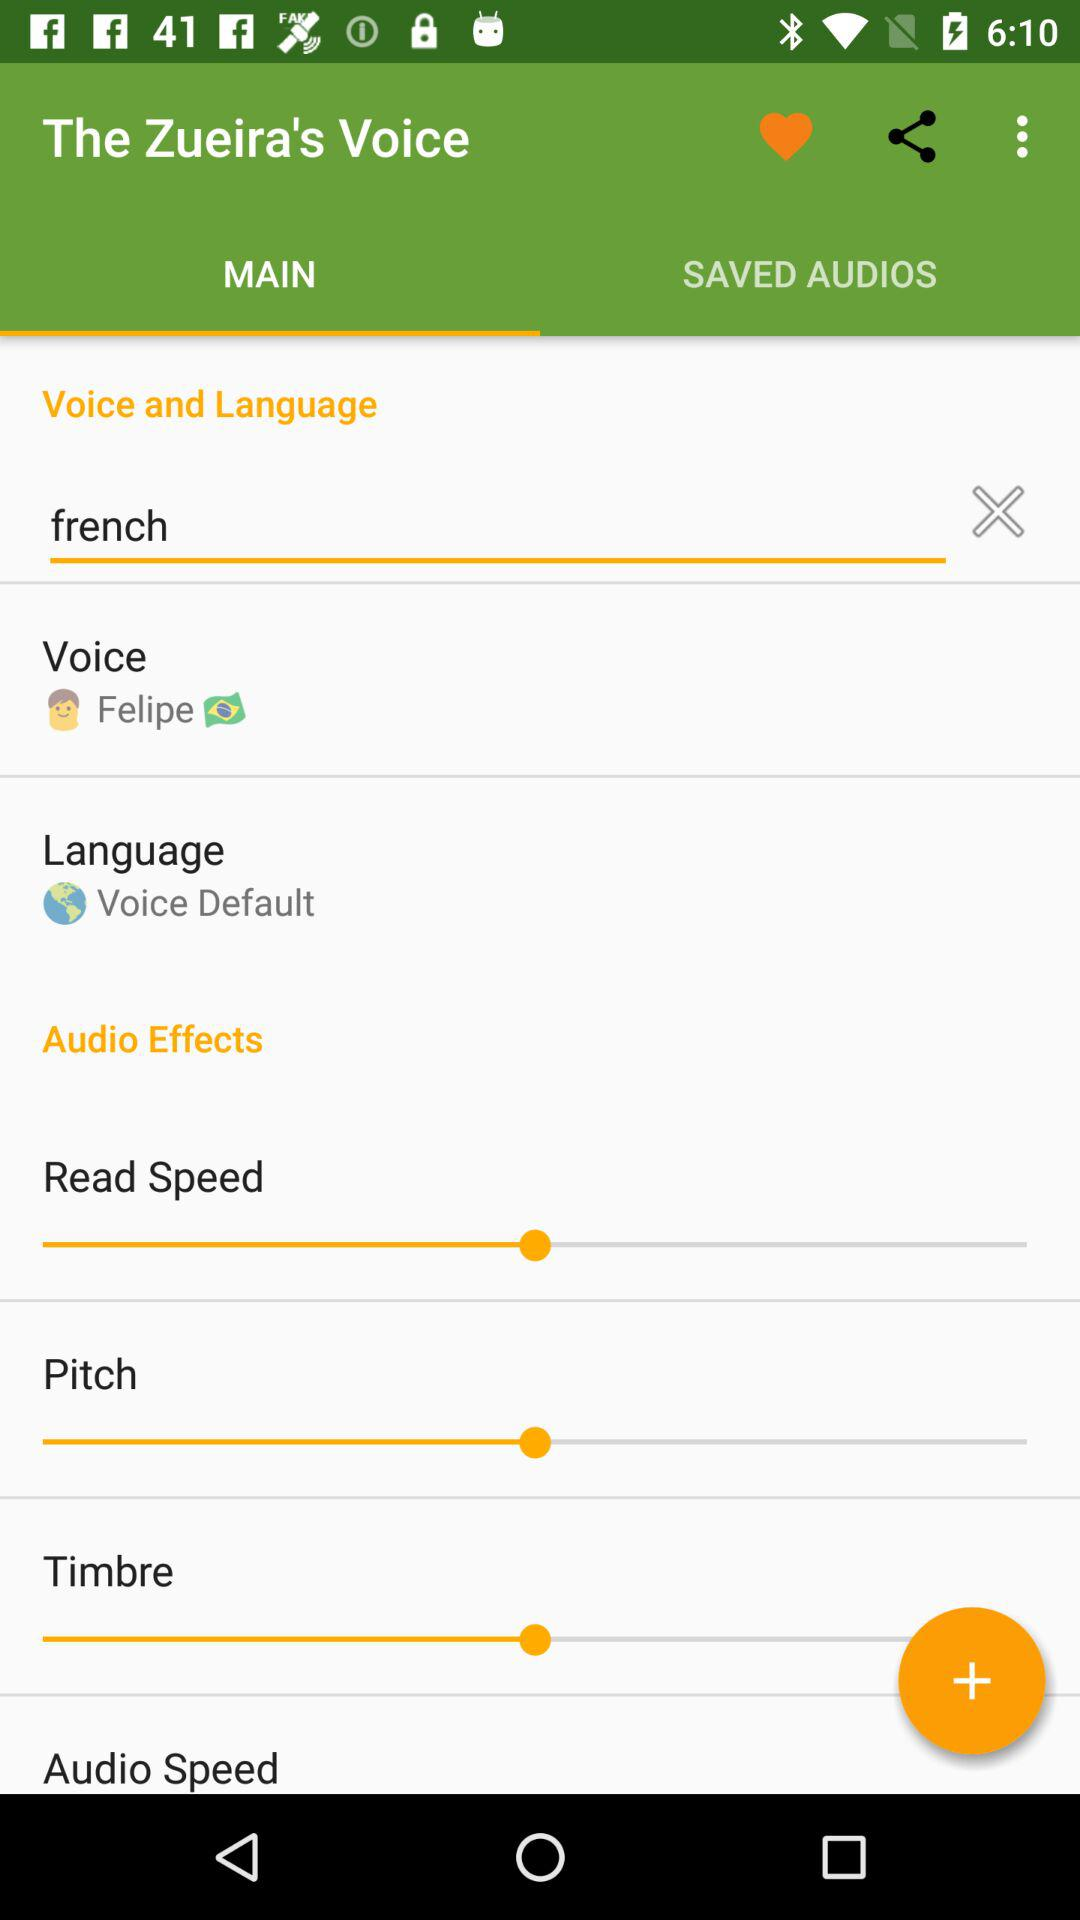What tab is selected? The selected tab is "MAIN". 